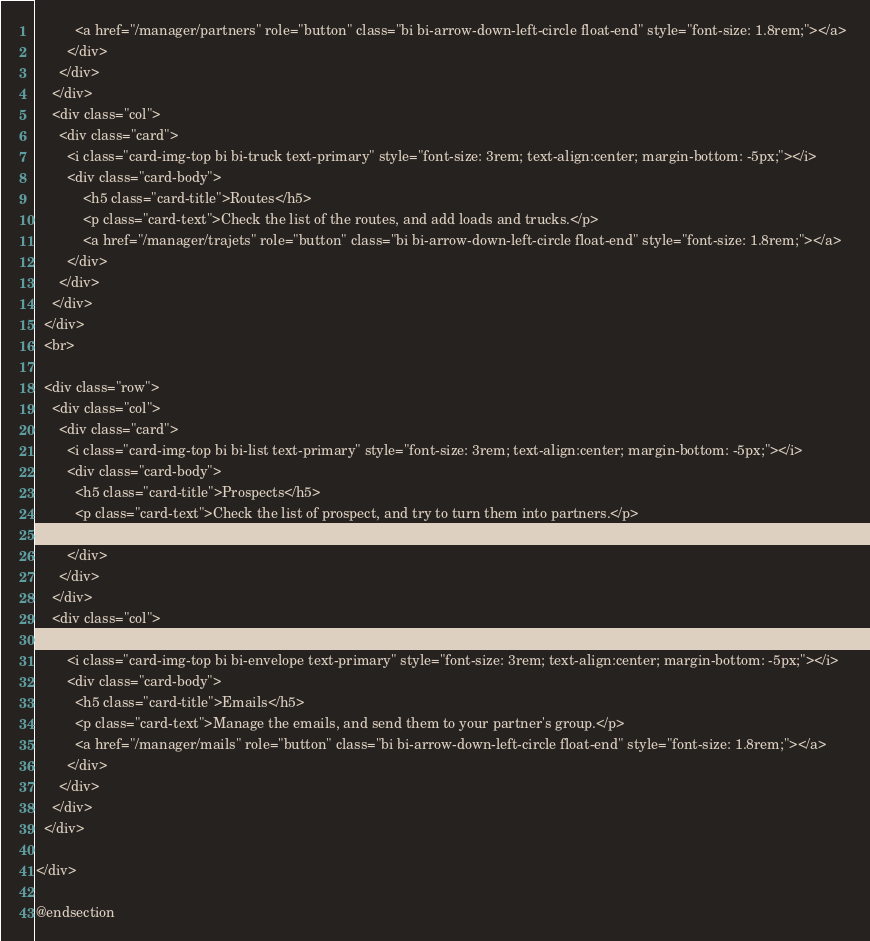<code> <loc_0><loc_0><loc_500><loc_500><_PHP_>          <a href="/manager/partners" role="button" class="bi bi-arrow-down-left-circle float-end" style="font-size: 1.8rem;"></a>
        </div>
      </div>
    </div>
    <div class="col">
      <div class="card">
        <i class="card-img-top bi bi-truck text-primary" style="font-size: 3rem; text-align:center; margin-bottom: -5px;"></i>
        <div class="card-body">
            <h5 class="card-title">Routes</h5>
            <p class="card-text">Check the list of the routes, and add loads and trucks.</p>
            <a href="/manager/trajets" role="button" class="bi bi-arrow-down-left-circle float-end" style="font-size: 1.8rem;"></a>
        </div>
      </div>
    </div>    
  </div>
  <br>
  
  <div class="row">
    <div class="col">    
      <div class="card">
        <i class="card-img-top bi bi-list text-primary" style="font-size: 3rem; text-align:center; margin-bottom: -5px;"></i>
        <div class="card-body">
          <h5 class="card-title">Prospects</h5>
          <p class="card-text">Check the list of prospect, and try to turn them into partners.</p>
          <a href="/manager/prospects" role="button" class="bi bi-arrow-down-left-circle float-end" style="font-size: 1.8rem;"></a>
        </div>
      </div>
    </div>
    <div class="col">    
      <div class="card">
        <i class="card-img-top bi bi-envelope text-primary" style="font-size: 3rem; text-align:center; margin-bottom: -5px;"></i>
        <div class="card-body">
          <h5 class="card-title">Emails</h5>
          <p class="card-text">Manage the emails, and send them to your partner's group.</p>
          <a href="/manager/mails" role="button" class="bi bi-arrow-down-left-circle float-end" style="font-size: 1.8rem;"></a>
        </div>
      </div>
    </div>
  </div>
    
</div>

@endsection</code> 